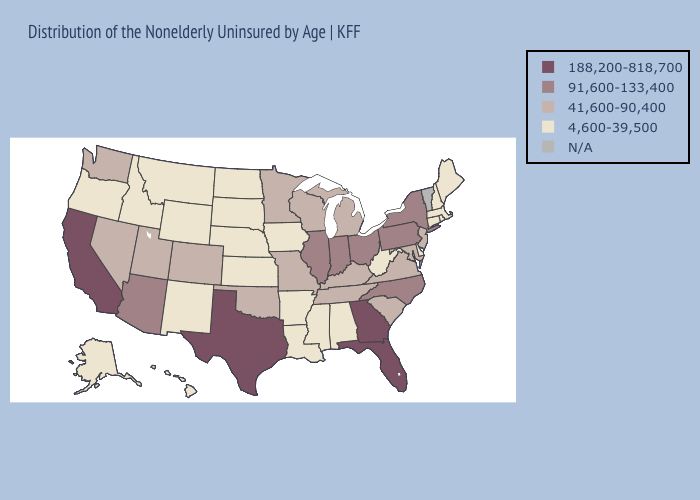What is the highest value in the South ?
Concise answer only. 188,200-818,700. Does Texas have the highest value in the USA?
Write a very short answer. Yes. Which states have the lowest value in the USA?
Write a very short answer. Alabama, Alaska, Arkansas, Connecticut, Delaware, Hawaii, Idaho, Iowa, Kansas, Louisiana, Maine, Massachusetts, Mississippi, Montana, Nebraska, New Hampshire, New Mexico, North Dakota, Oregon, Rhode Island, South Dakota, West Virginia, Wyoming. What is the highest value in the USA?
Write a very short answer. 188,200-818,700. Name the states that have a value in the range 91,600-133,400?
Be succinct. Arizona, Illinois, Indiana, New York, North Carolina, Ohio, Pennsylvania. Does South Carolina have the highest value in the USA?
Be succinct. No. What is the value of Minnesota?
Give a very brief answer. 41,600-90,400. What is the value of Kansas?
Short answer required. 4,600-39,500. What is the value of Wyoming?
Concise answer only. 4,600-39,500. What is the value of Illinois?
Concise answer only. 91,600-133,400. Which states have the lowest value in the South?
Give a very brief answer. Alabama, Arkansas, Delaware, Louisiana, Mississippi, West Virginia. Which states hav the highest value in the South?
Quick response, please. Florida, Georgia, Texas. What is the value of Kentucky?
Give a very brief answer. 41,600-90,400. What is the value of Oklahoma?
Keep it brief. 41,600-90,400. 